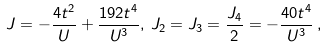Convert formula to latex. <formula><loc_0><loc_0><loc_500><loc_500>J = - \frac { 4 t ^ { 2 } } { U } + \frac { 1 9 2 t ^ { 4 } } { U ^ { 3 } } , \, J _ { 2 } = J _ { 3 } = \frac { J _ { 4 } } { 2 } = - \frac { 4 0 t ^ { 4 } } { U ^ { 3 } } \, ,</formula> 